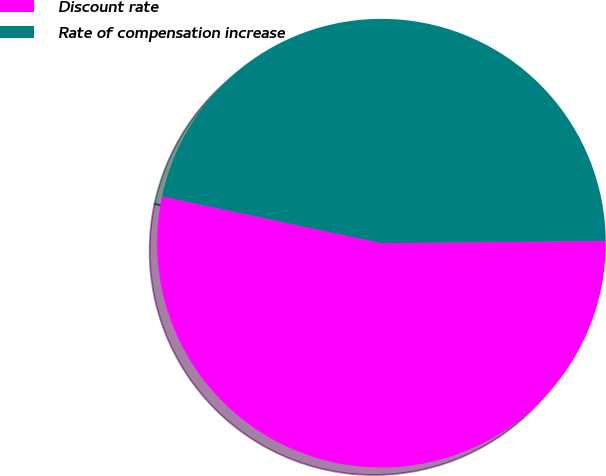<chart> <loc_0><loc_0><loc_500><loc_500><pie_chart><fcel>Discount rate<fcel>Rate of compensation increase<nl><fcel>53.49%<fcel>46.51%<nl></chart> 